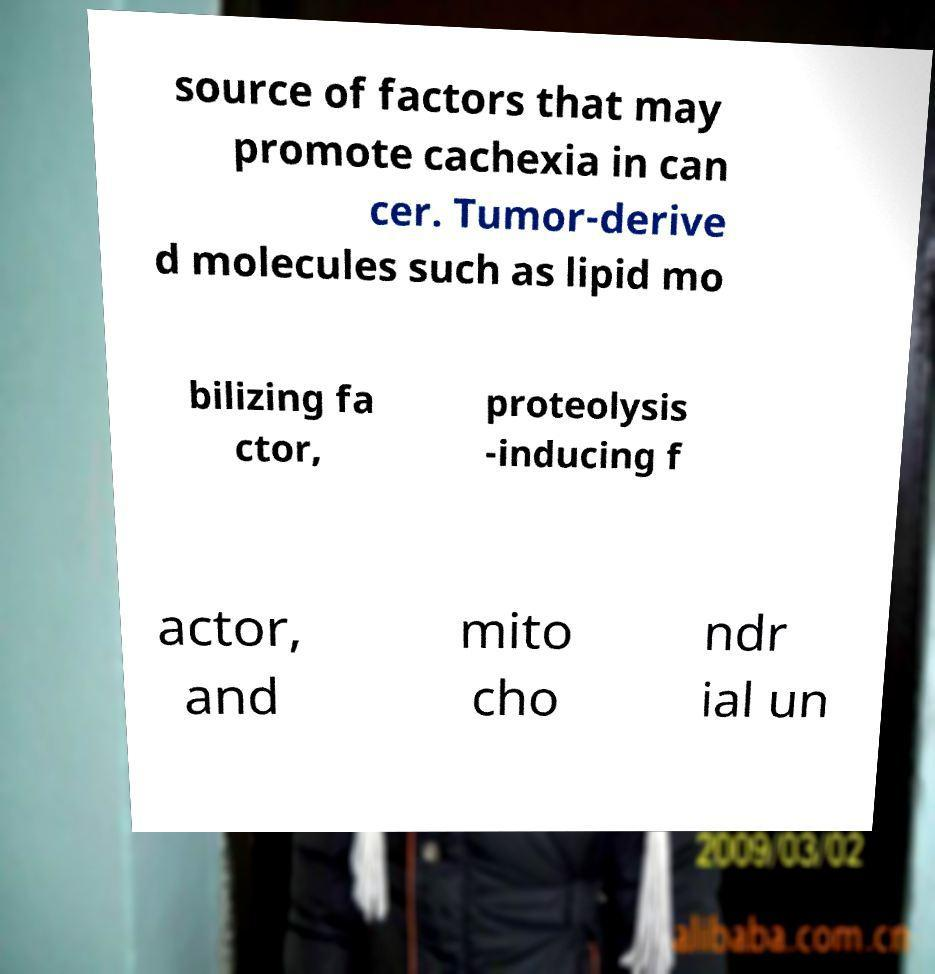Please read and relay the text visible in this image. What does it say? source of factors that may promote cachexia in can cer. Tumor-derive d molecules such as lipid mo bilizing fa ctor, proteolysis -inducing f actor, and mito cho ndr ial un 